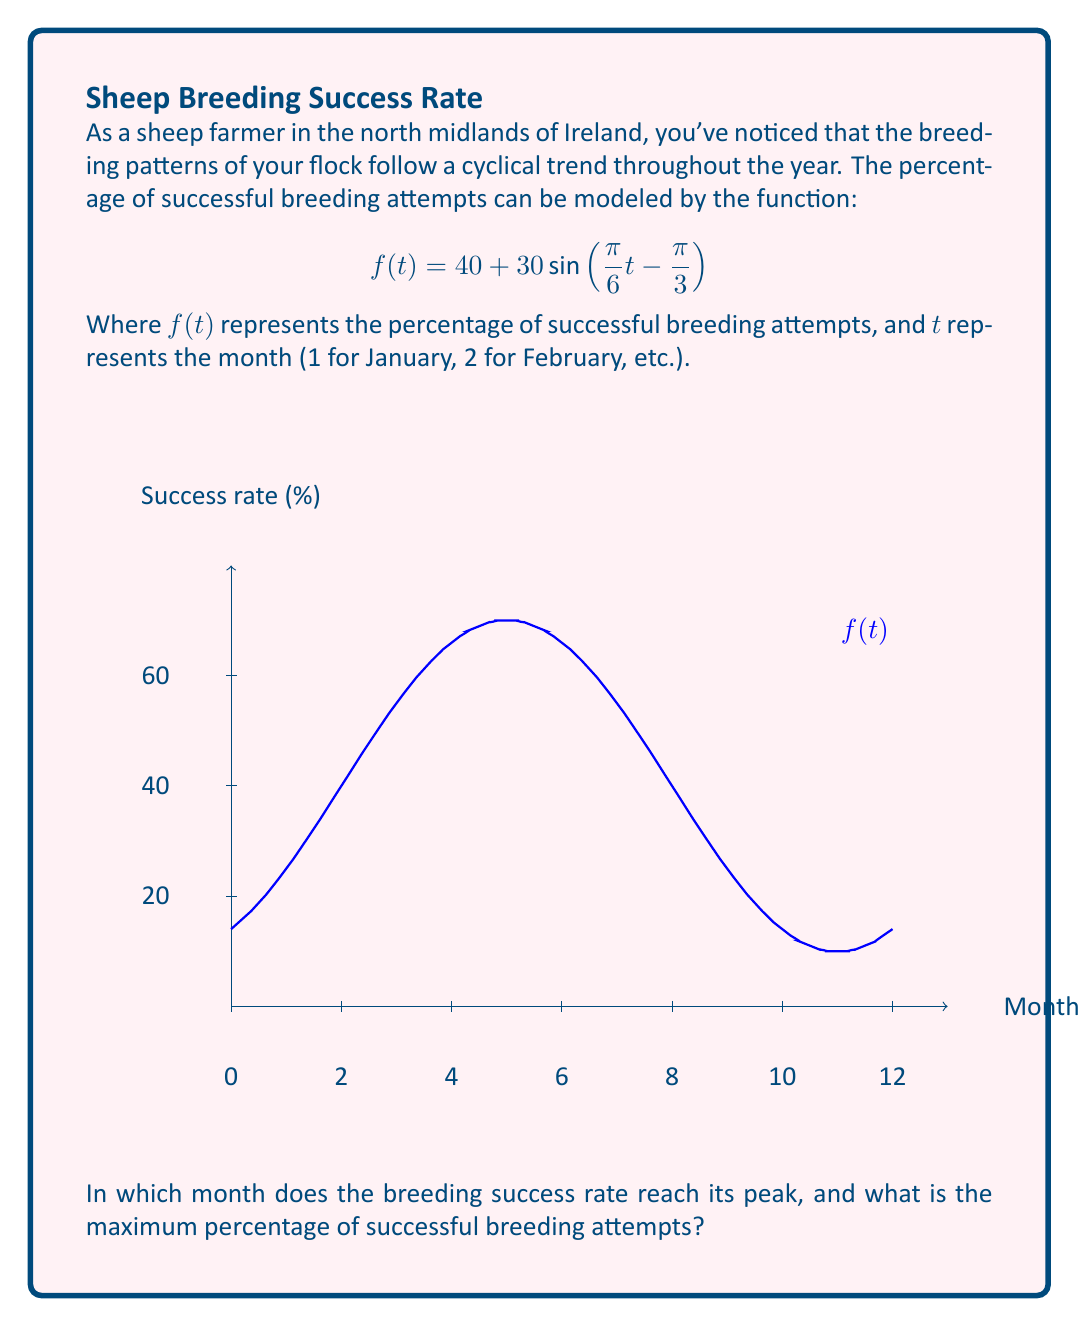Teach me how to tackle this problem. Let's approach this step-by-step:

1) The breeding success rate is at its maximum when the sine function reaches its peak. This occurs when the argument of sine is $\frac{\pi}{2}$.

2) We need to solve the equation:

   $$\frac{\pi}{6}t - \frac{\pi}{3} = \frac{\pi}{2}$$

3) Solving for $t$:
   
   $$\frac{\pi}{6}t = \frac{\pi}{2} + \frac{\pi}{3} = \frac{5\pi}{6}$$
   
   $$t = \frac{5\pi}{6} \div \frac{\pi}{6} = 5$$

4) Since $t$ represents months, and we start counting from January (1), the 5th month is May.

5) To find the maximum percentage, we substitute $t=5$ into our original function:

   $$f(5) = 40 + 30\sin\left(\frac{\pi}{6}(5) - \frac{\pi}{3}\right)$$
   
   $$= 40 + 30\sin\left(\frac{5\pi}{6} - \frac{\pi}{3}\right)$$
   
   $$= 40 + 30\sin\left(\frac{\pi}{2}\right)$$
   
   $$= 40 + 30(1) = 70$$

Therefore, the breeding success rate reaches its peak in May with a maximum of 70% successful breeding attempts.
Answer: May, 70% 